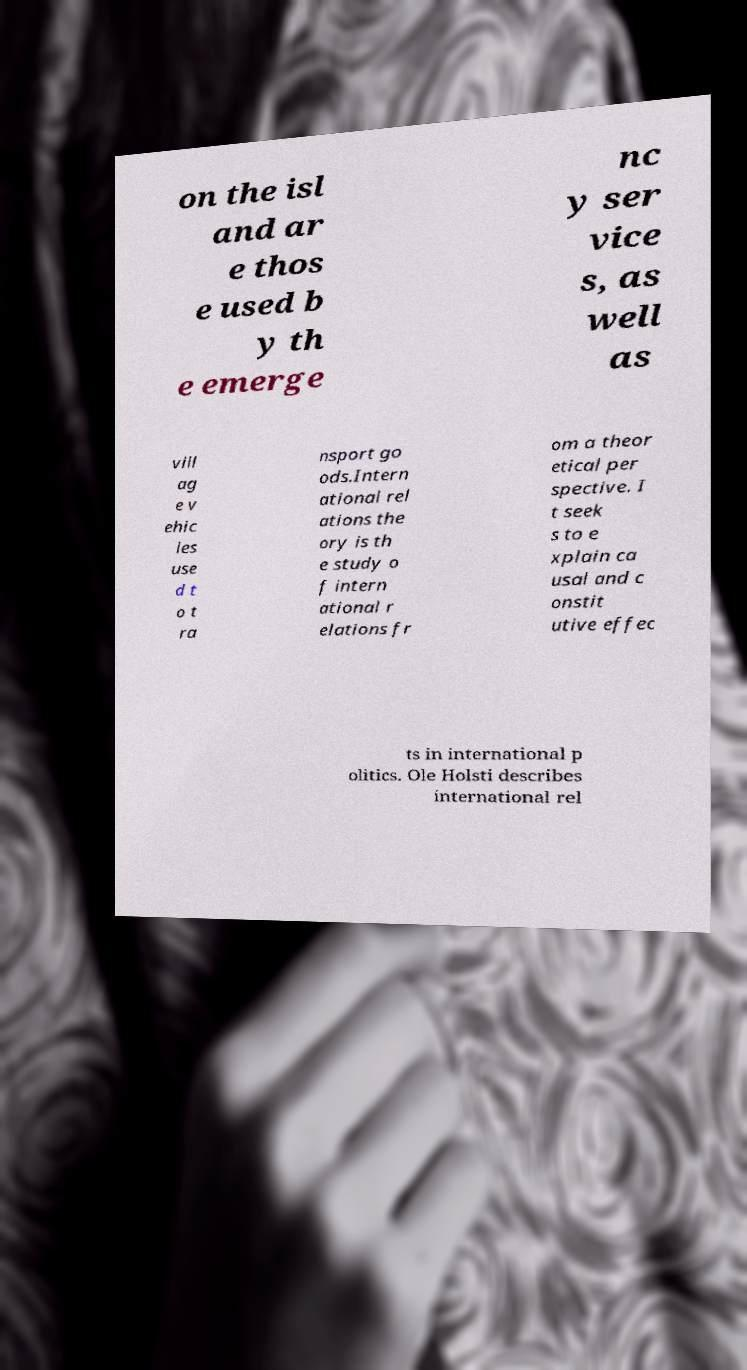Please read and relay the text visible in this image. What does it say? on the isl and ar e thos e used b y th e emerge nc y ser vice s, as well as vill ag e v ehic les use d t o t ra nsport go ods.Intern ational rel ations the ory is th e study o f intern ational r elations fr om a theor etical per spective. I t seek s to e xplain ca usal and c onstit utive effec ts in international p olitics. Ole Holsti describes international rel 